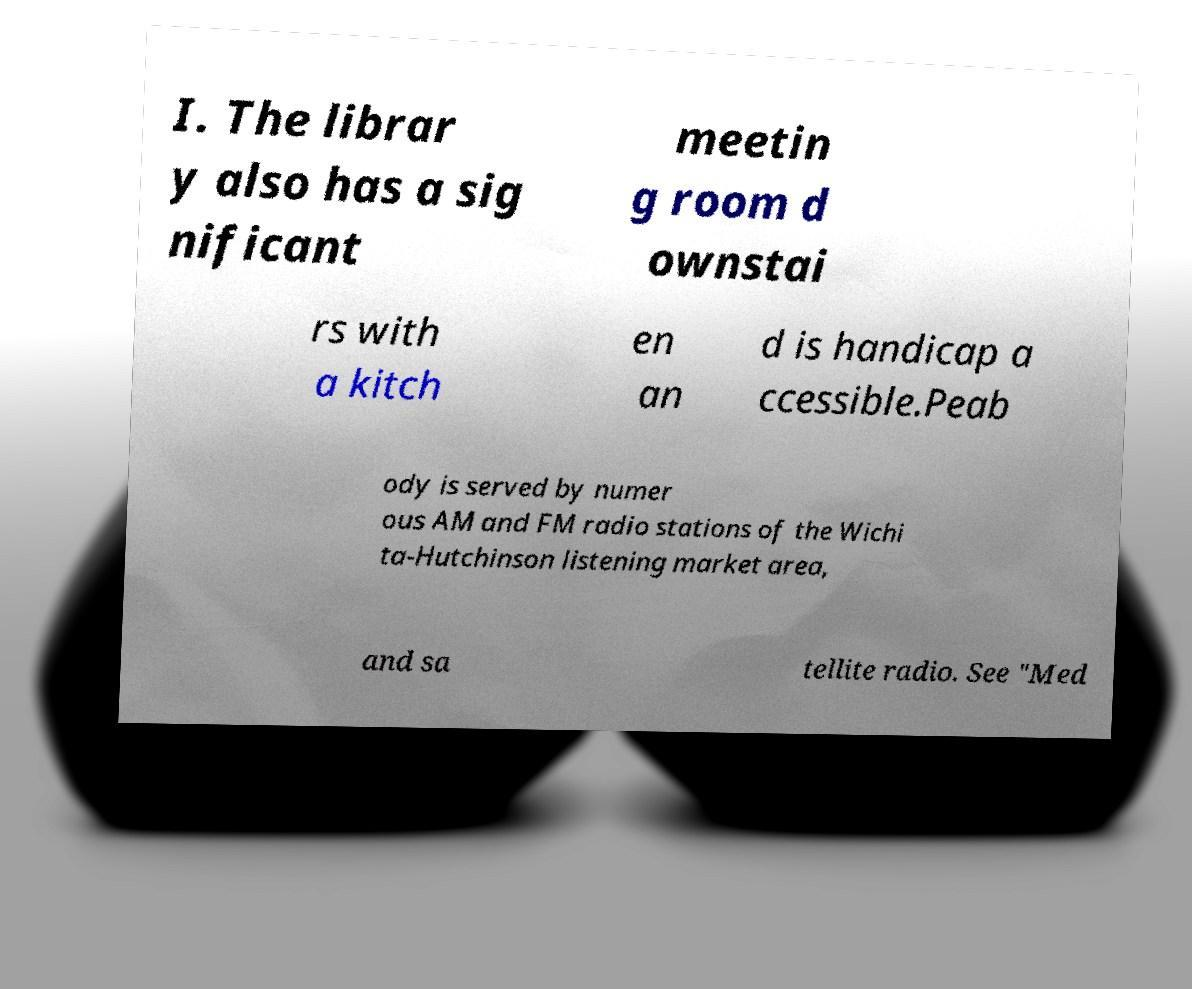Please read and relay the text visible in this image. What does it say? I. The librar y also has a sig nificant meetin g room d ownstai rs with a kitch en an d is handicap a ccessible.Peab ody is served by numer ous AM and FM radio stations of the Wichi ta-Hutchinson listening market area, and sa tellite radio. See "Med 